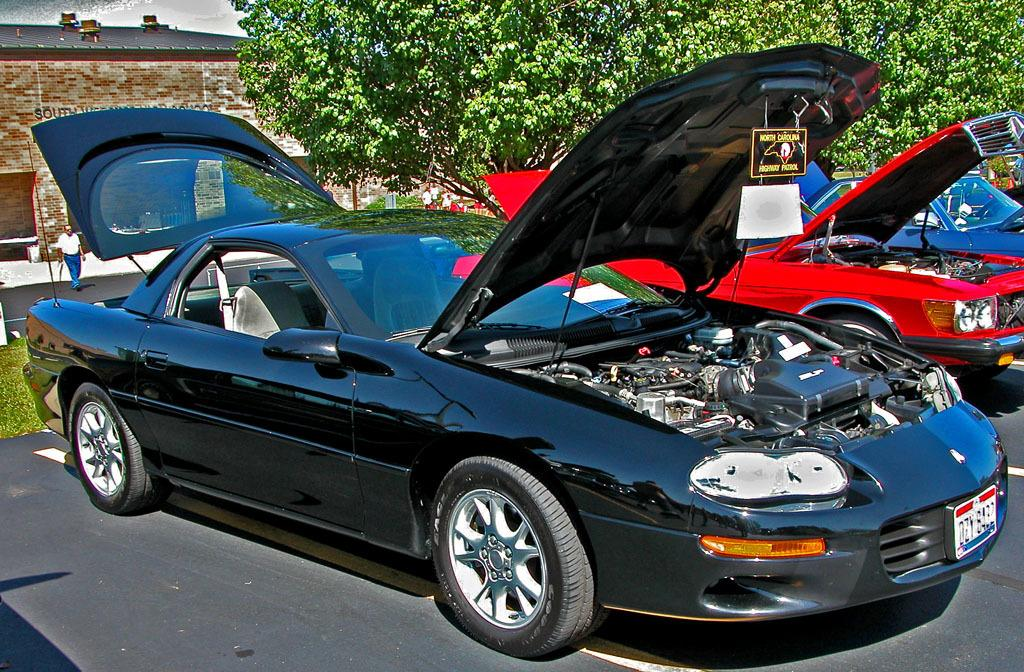What can be seen on the road in the image? There are cars parked on the road. What is visible in the background of the image? There is a building and trees in the background. Can you describe the person in the image? There is a person walking on the road. What story does the person walking on the road believe in? There is no information about the person's beliefs or stories in the image, so it cannot be determined. 